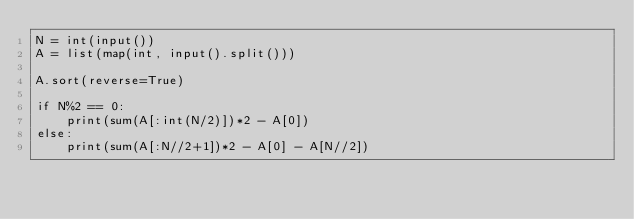<code> <loc_0><loc_0><loc_500><loc_500><_Python_>N = int(input())
A = list(map(int, input().split()))

A.sort(reverse=True)

if N%2 == 0:
    print(sum(A[:int(N/2)])*2 - A[0])
else:
    print(sum(A[:N//2+1])*2 - A[0] - A[N//2])

</code> 